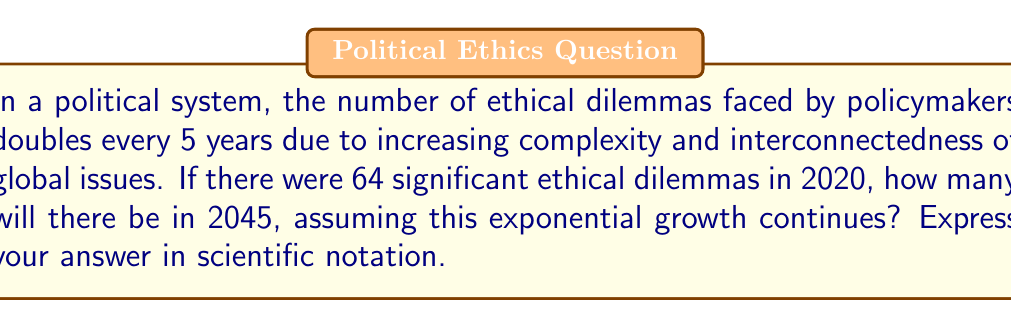Show me your answer to this math problem. Let's approach this step-by-step:

1) First, we need to determine how many 5-year periods are between 2020 and 2045:
   $\frac{2045 - 2020}{5} = 5$ periods

2) We're told that the number of dilemmas doubles every 5 years. This means we're dealing with exponential growth with a base of 2:
   $64 \cdot 2^5$

3) Let's calculate this:
   $64 \cdot 2^5 = 64 \cdot 32 = 2048$

4) To express this in scientific notation, we move the decimal point to the left until we have a number between 1 and 10, then count how many places we moved:
   $2048 = 2.048 \times 10^3$

Therefore, in 2045, there will be $2.048 \times 10^3$ significant ethical dilemmas.

This exponential growth model illustrates the rapidly increasing complexity of ethical decision-making in politics over time, a concept that aligns with discussions on moral relativism and its impact on political landscapes.
Answer: $2.048 \times 10^3$ 